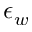Convert formula to latex. <formula><loc_0><loc_0><loc_500><loc_500>\epsilon _ { w }</formula> 